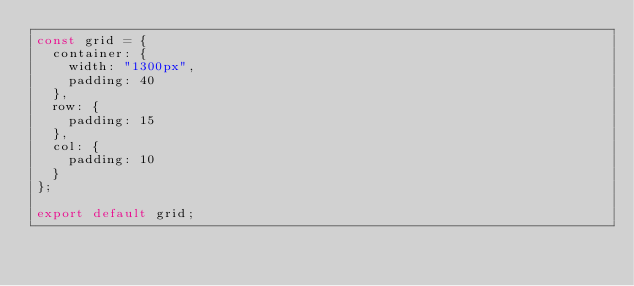Convert code to text. <code><loc_0><loc_0><loc_500><loc_500><_TypeScript_>const grid = {
  container: {
    width: "1300px",
    padding: 40
  },
  row: {
    padding: 15
  },
  col: {
    padding: 10
  }
};

export default grid;
</code> 